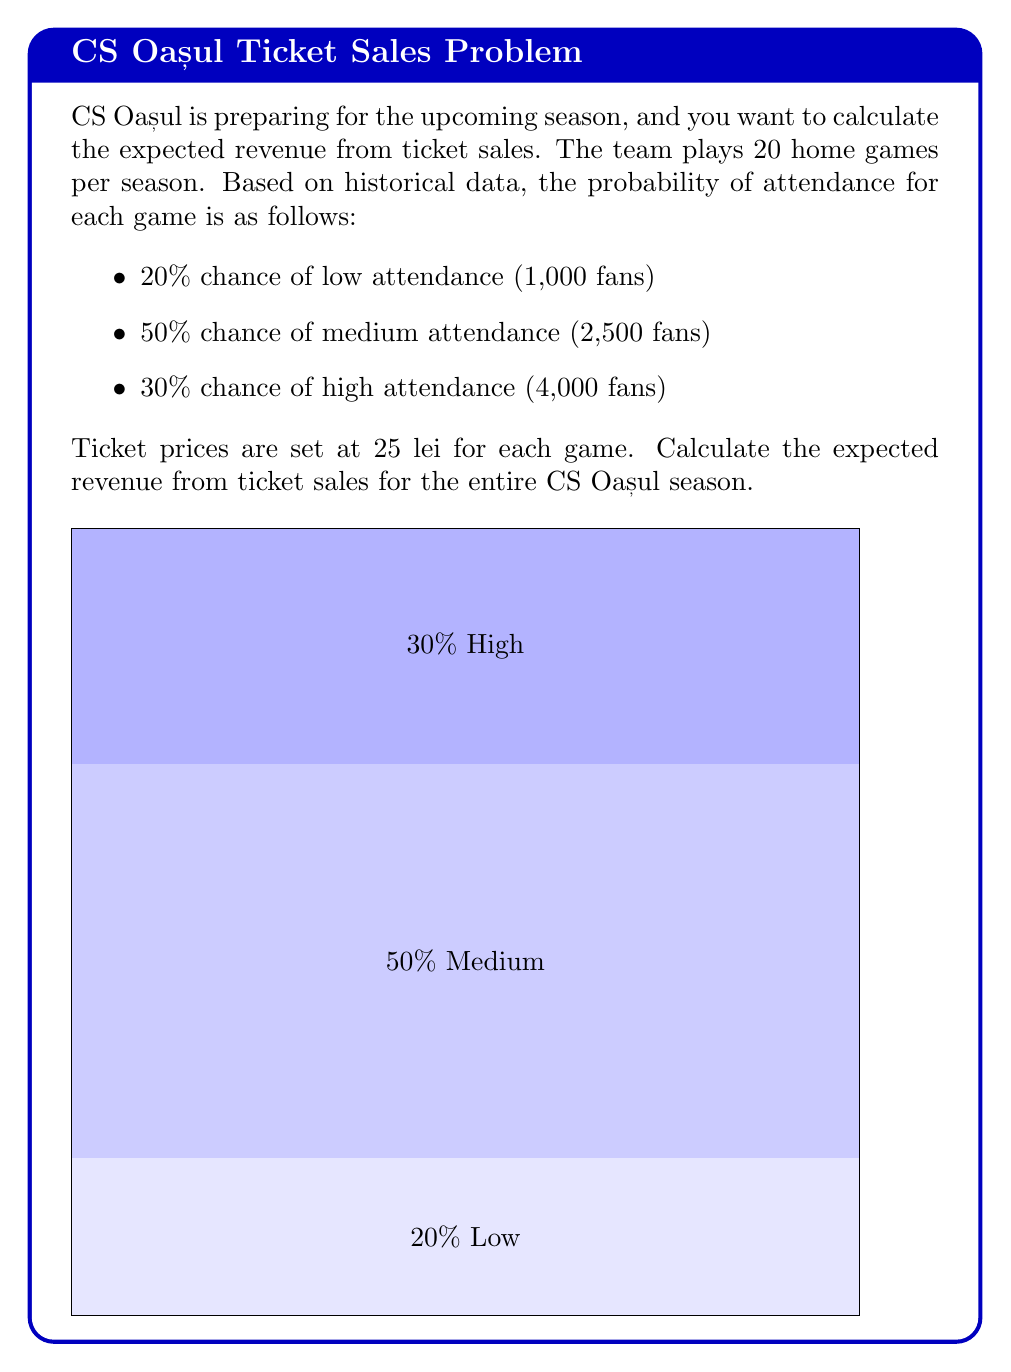Teach me how to tackle this problem. Let's approach this problem step-by-step:

1) First, we need to calculate the expected attendance for a single game:

   $E(\text{attendance}) = (0.2 \times 1000) + (0.5 \times 2500) + (0.3 \times 4000)$
   $= 200 + 1250 + 1200 = 2650$ fans

2) Now, we can calculate the expected revenue for a single game:

   $E(\text{revenue per game}) = E(\text{attendance}) \times \text{ticket price}$
   $= 2650 \times 25 = 66,250$ lei

3) For the entire season (20 home games), we multiply this by 20:

   $E(\text{season revenue}) = E(\text{revenue per game}) \times \text{number of games}$
   $= 66,250 \times 20 = 1,325,000$ lei

Therefore, the expected revenue from ticket sales for the entire CS Oașul season is 1,325,000 lei.
Answer: $$1,325,000\text{ lei}$$ 